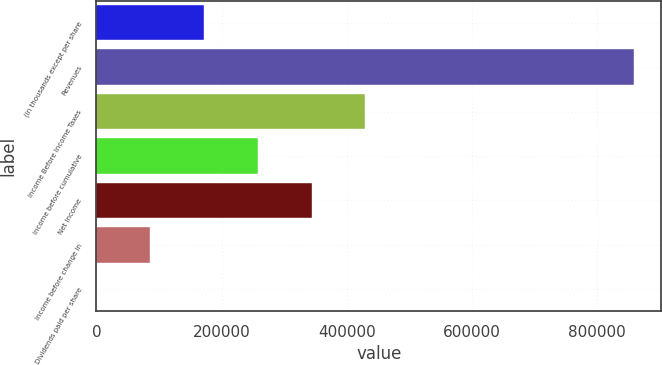Convert chart. <chart><loc_0><loc_0><loc_500><loc_500><bar_chart><fcel>(in thousands except per share<fcel>Revenues<fcel>Income Before Income Taxes<fcel>Income before cumulative<fcel>Net Income<fcel>Income before change in<fcel>Dividends paid per share<nl><fcel>171776<fcel>858878<fcel>429439<fcel>257664<fcel>343551<fcel>85888<fcel>0.25<nl></chart> 